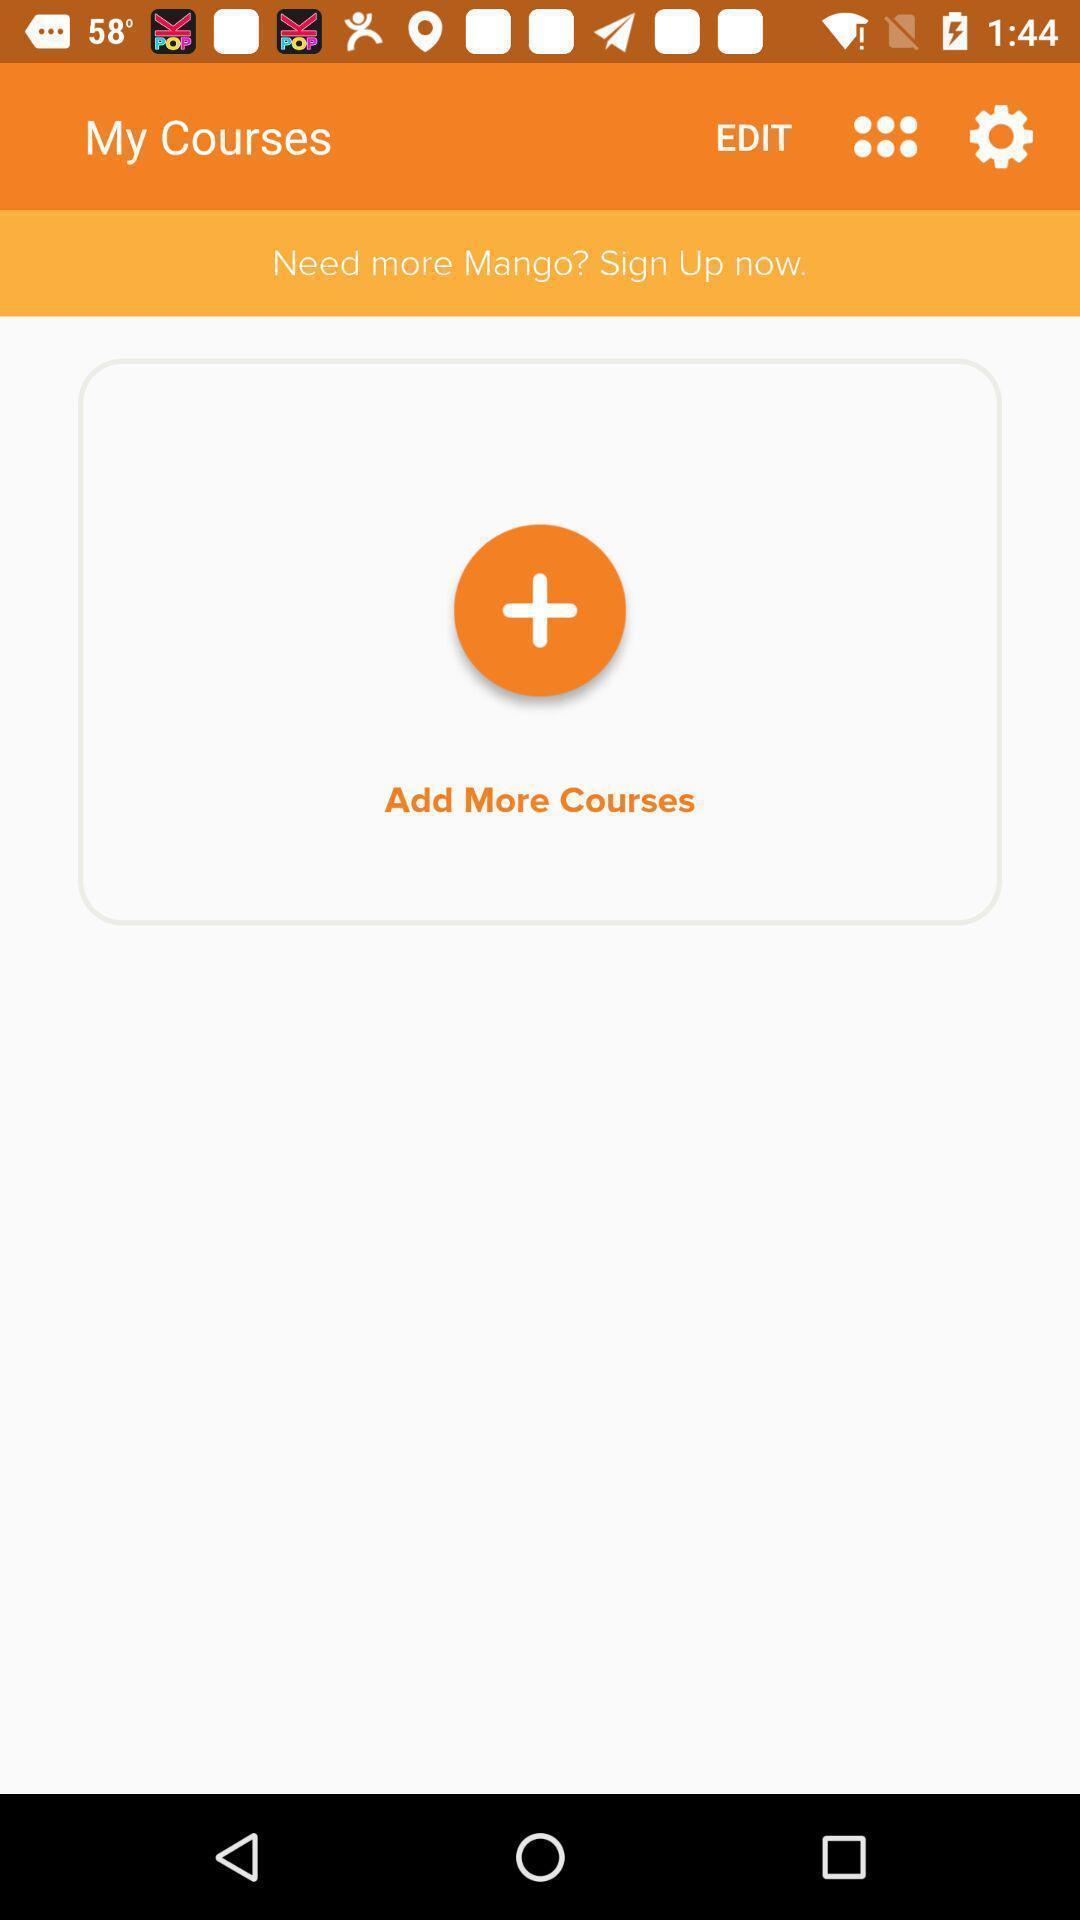Tell me about the visual elements in this screen capture. Screen shows courses details in a learning app. 